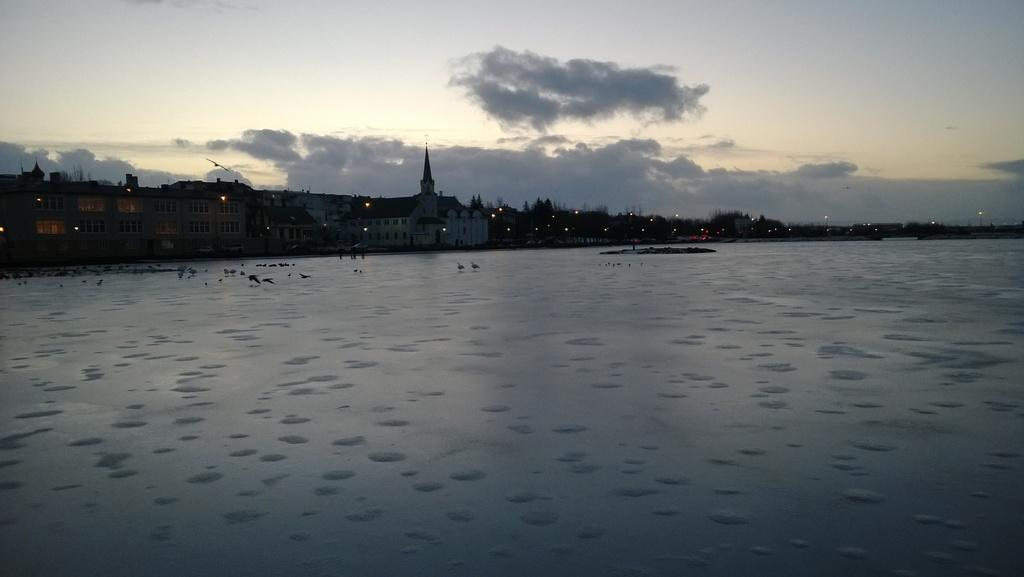What is the primary element in the image? There is water in the image. What is present within the water? There are birds in the water. What can be seen in the background of the image? There are buildings and trees in the background of the image. What is visible at the top of the image? The sky with clouds is visible at the top of the image. What type of celery can be seen growing near the water in the image? There is no celery present in the image; it features water with birds and a background of buildings and trees. 